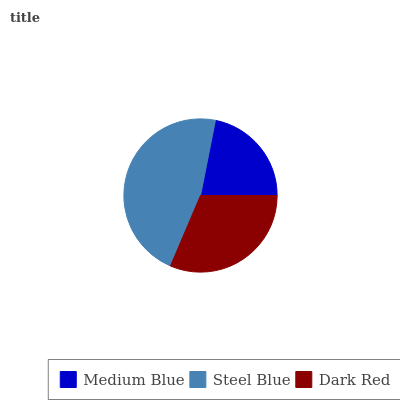Is Medium Blue the minimum?
Answer yes or no. Yes. Is Steel Blue the maximum?
Answer yes or no. Yes. Is Dark Red the minimum?
Answer yes or no. No. Is Dark Red the maximum?
Answer yes or no. No. Is Steel Blue greater than Dark Red?
Answer yes or no. Yes. Is Dark Red less than Steel Blue?
Answer yes or no. Yes. Is Dark Red greater than Steel Blue?
Answer yes or no. No. Is Steel Blue less than Dark Red?
Answer yes or no. No. Is Dark Red the high median?
Answer yes or no. Yes. Is Dark Red the low median?
Answer yes or no. Yes. Is Medium Blue the high median?
Answer yes or no. No. Is Steel Blue the low median?
Answer yes or no. No. 